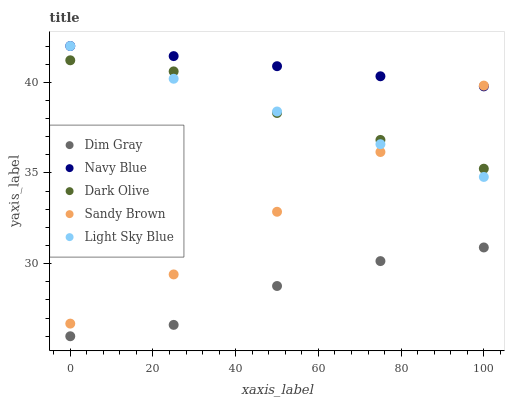Does Dim Gray have the minimum area under the curve?
Answer yes or no. Yes. Does Navy Blue have the maximum area under the curve?
Answer yes or no. Yes. Does Navy Blue have the minimum area under the curve?
Answer yes or no. No. Does Dim Gray have the maximum area under the curve?
Answer yes or no. No. Is Navy Blue the smoothest?
Answer yes or no. Yes. Is Dim Gray the roughest?
Answer yes or no. Yes. Is Dim Gray the smoothest?
Answer yes or no. No. Is Navy Blue the roughest?
Answer yes or no. No. Does Dim Gray have the lowest value?
Answer yes or no. Yes. Does Navy Blue have the lowest value?
Answer yes or no. No. Does Light Sky Blue have the highest value?
Answer yes or no. Yes. Does Dim Gray have the highest value?
Answer yes or no. No. Is Dim Gray less than Light Sky Blue?
Answer yes or no. Yes. Is Light Sky Blue greater than Dim Gray?
Answer yes or no. Yes. Does Light Sky Blue intersect Navy Blue?
Answer yes or no. Yes. Is Light Sky Blue less than Navy Blue?
Answer yes or no. No. Is Light Sky Blue greater than Navy Blue?
Answer yes or no. No. Does Dim Gray intersect Light Sky Blue?
Answer yes or no. No. 